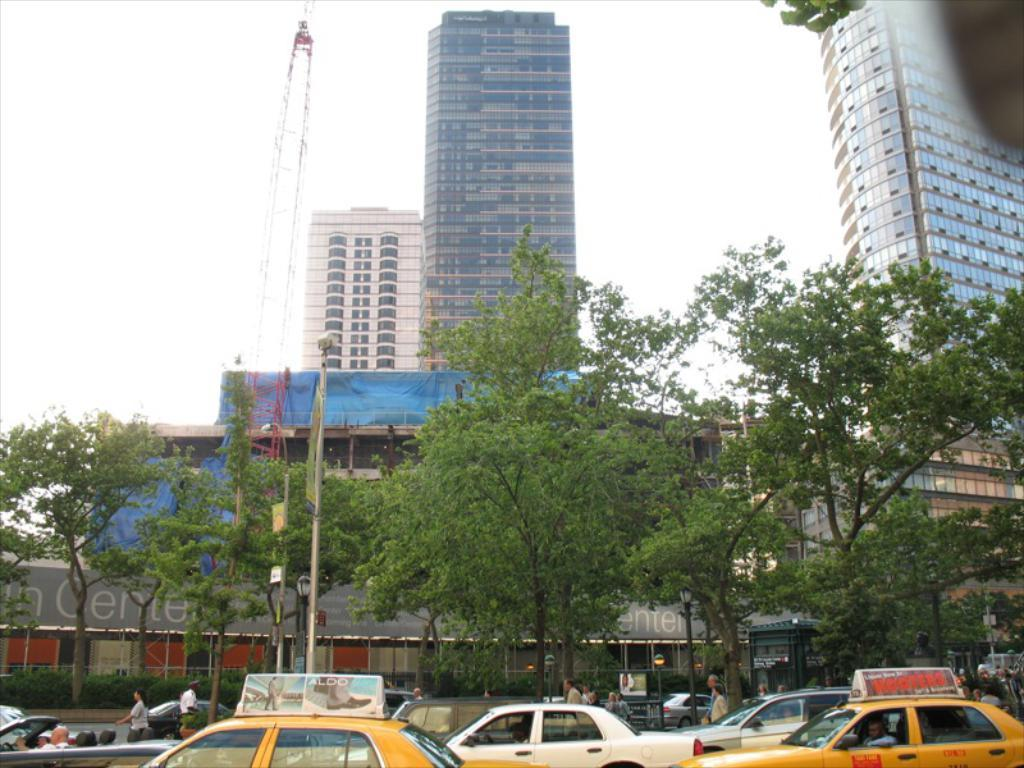<image>
Relay a brief, clear account of the picture shown. Taxis in traffic, one of which has an ad for Hooters on the top. 